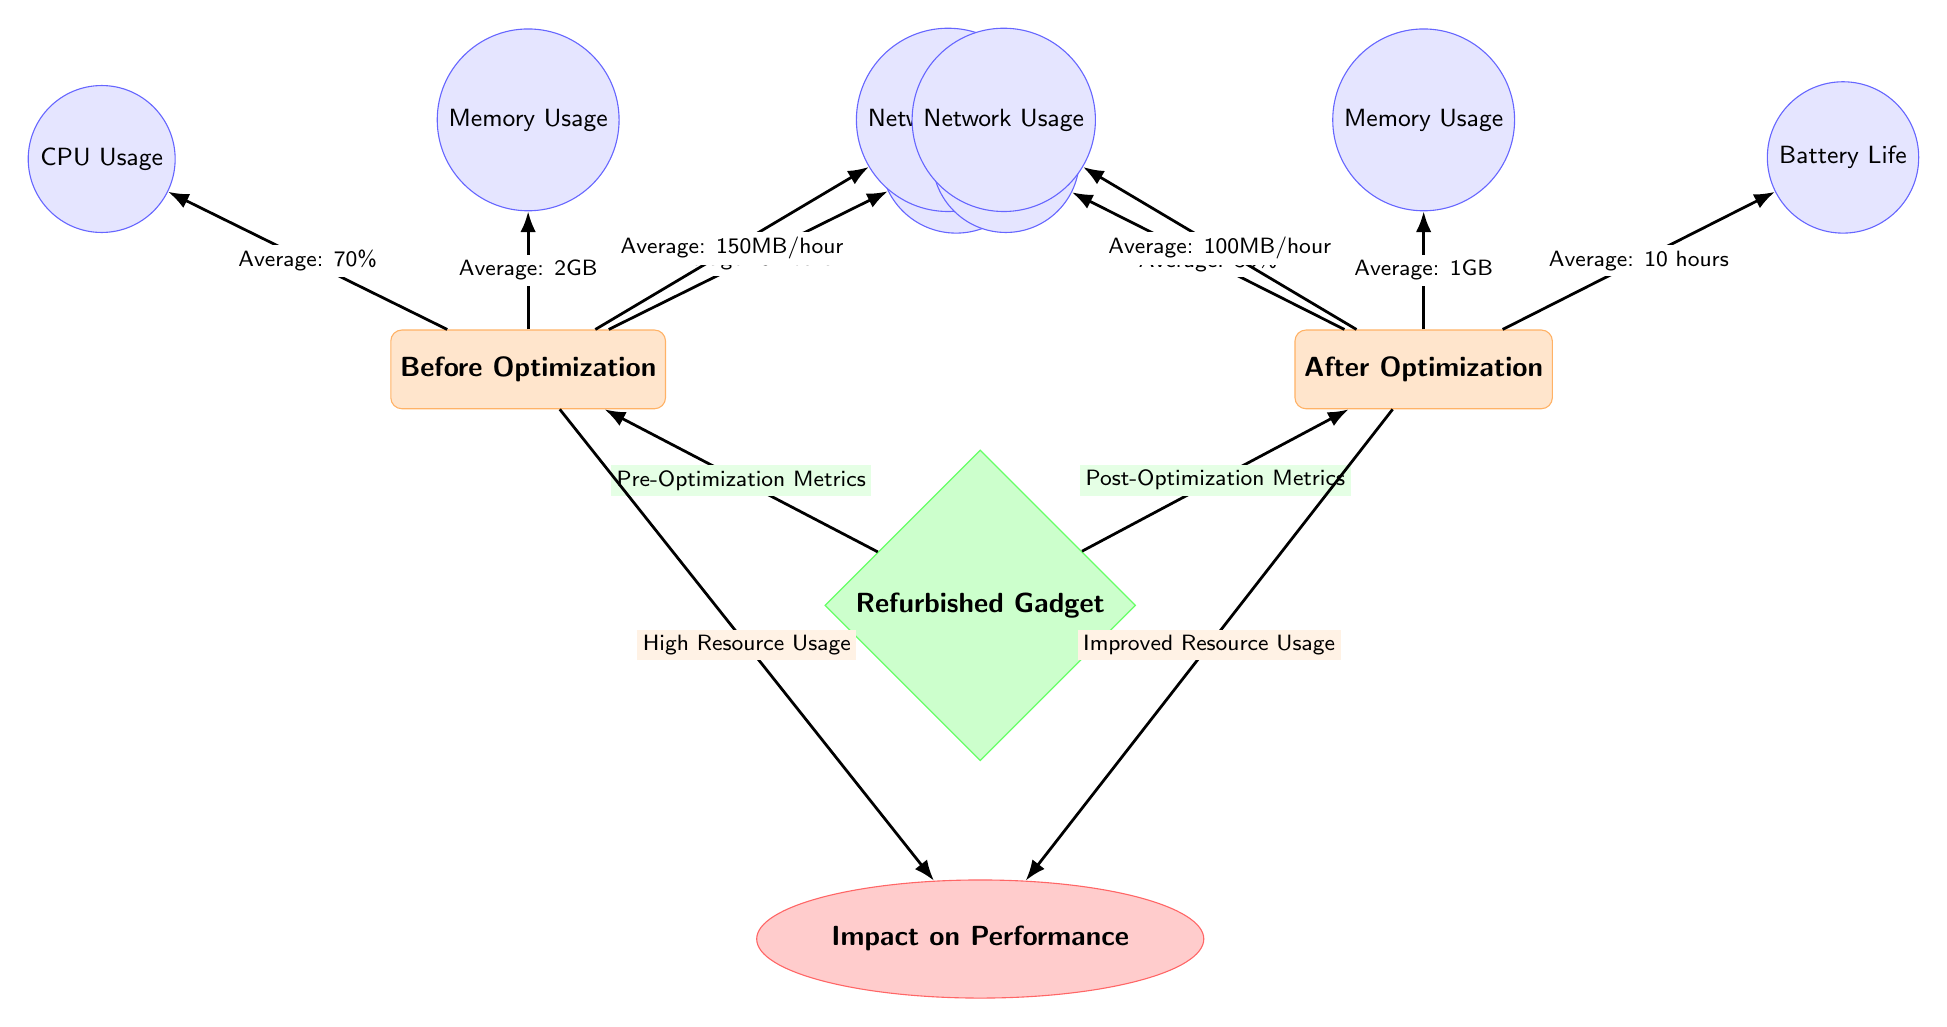What is the average CPU usage before optimization? The diagram indicates the average CPU usage before optimization is represented next to the CPU Usage metric under the "Before Optimization" category. The label shows "Average: 70%."
Answer: 70% What is the average memory usage after optimization? The diagram shows the average memory usage after optimization next to the Memory Usage metric under the "After Optimization" category. The label states "Average: 1GB."
Answer: 1GB Which category has the higher average battery life? The battery life metrics are shown for both "Before Optimization" and "After Optimization." The "Before" category states an average of "6 hours," while the "After" category states "10 hours." Thus, the "After Optimization" category has a higher average battery life.
Answer: After Optimization What is the average network usage before optimization? The average network usage before optimization can be found next to the Network Usage metric in the "Before Optimization" category, which is labeled as "Average: 150MB/hour."
Answer: 150MB/hour How does the impact on performance change from before to after optimization? The impact on performance is shown to change from "High Resource Usage" under the "Before Optimization" category to "Improved Resource Usage" under the "After Optimization" category. This indicates a positive change in performance impact after optimization.
Answer: Improved Resource Usage What is the average CPU usage after optimization? The diagram provides the average CPU usage after optimization next to the CPU Usage metric in the "After Optimization" category, which reads "Average: 35%."
Answer: 35% What can be inferred about memory usage before and after optimization? Comparing the memory usage from the "Before Optimization" category, which shows "Average: 2GB," to the "After Optimization" category, which shows "Average: 1GB," we can infer that memory usage decreased after optimization.
Answer: Decreased How many metrics are measured in the "Before Optimization" category? The "Before Optimization" category lists four metrics: CPU Usage, Memory Usage, Battery Life, and Network Usage. Thus, there are four metrics measured.
Answer: 4 